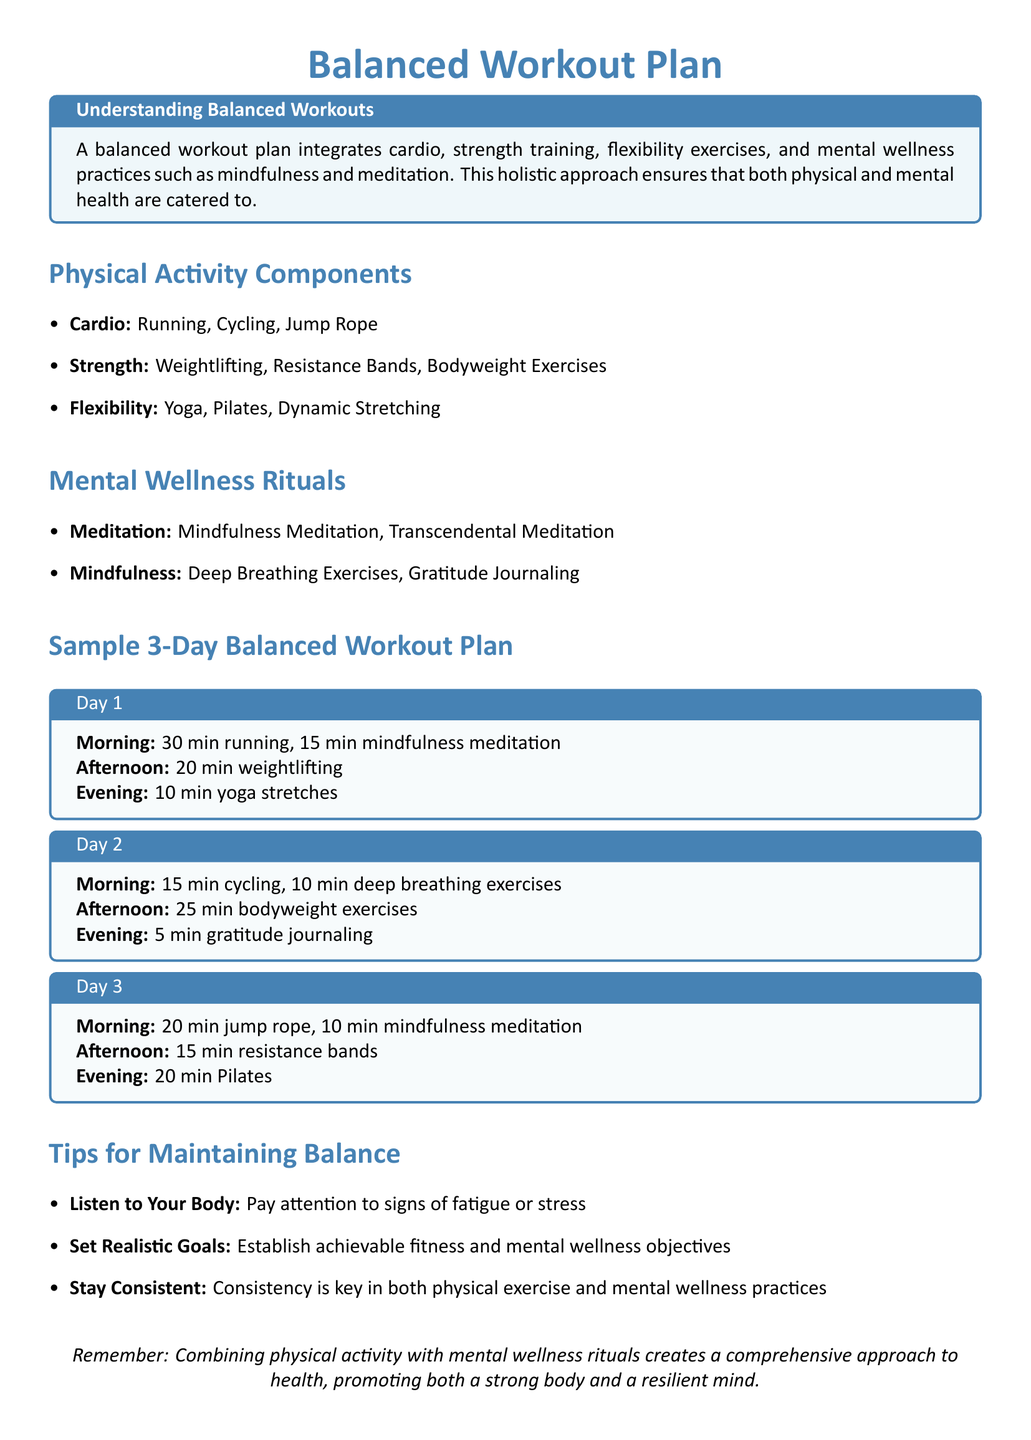What are the three components of physical activity? The document lists cardio, strength training, and flexibility exercises as the three components of physical activity.
Answer: Cardio, strength, flexibility How long is the morning session on Day 1? The morning session on Day 1 consists of 30 minutes of running followed by 15 minutes of mindfulness meditation, totaling 45 minutes.
Answer: 30 min running What is one example of a mental wellness ritual mentioned? The document includes mindfulness meditation and deep breathing exercises as examples of mental wellness rituals.
Answer: Mindfulness meditation How many minutes are dedicated to weightlifting on Day 1? According to the Day 1 schedule, 20 minutes are allocated for weightlifting.
Answer: 20 min What is the main focus of a balanced workout plan? The document emphasizes integrating cardio, strength training, flexibility exercises, and mental wellness practices for a holistic approach.
Answer: Integrates cardio, strength, flexibility, and mental wellness Which day includes gratitude journaling? The sample workout plan specifies gratitude journaling during the evening session of Day 2.
Answer: Day 2 What should you listen to while working out? The document advises listeners to pay attention to signs of fatigue or stress during workouts.
Answer: Your body What is emphasized as key for maintaining balance? The document highlights that consistency is essential for both physical exercise and mental wellness practices.
Answer: Consistency 